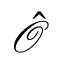<formula> <loc_0><loc_0><loc_500><loc_500>\hat { \mathcal { O } }</formula> 